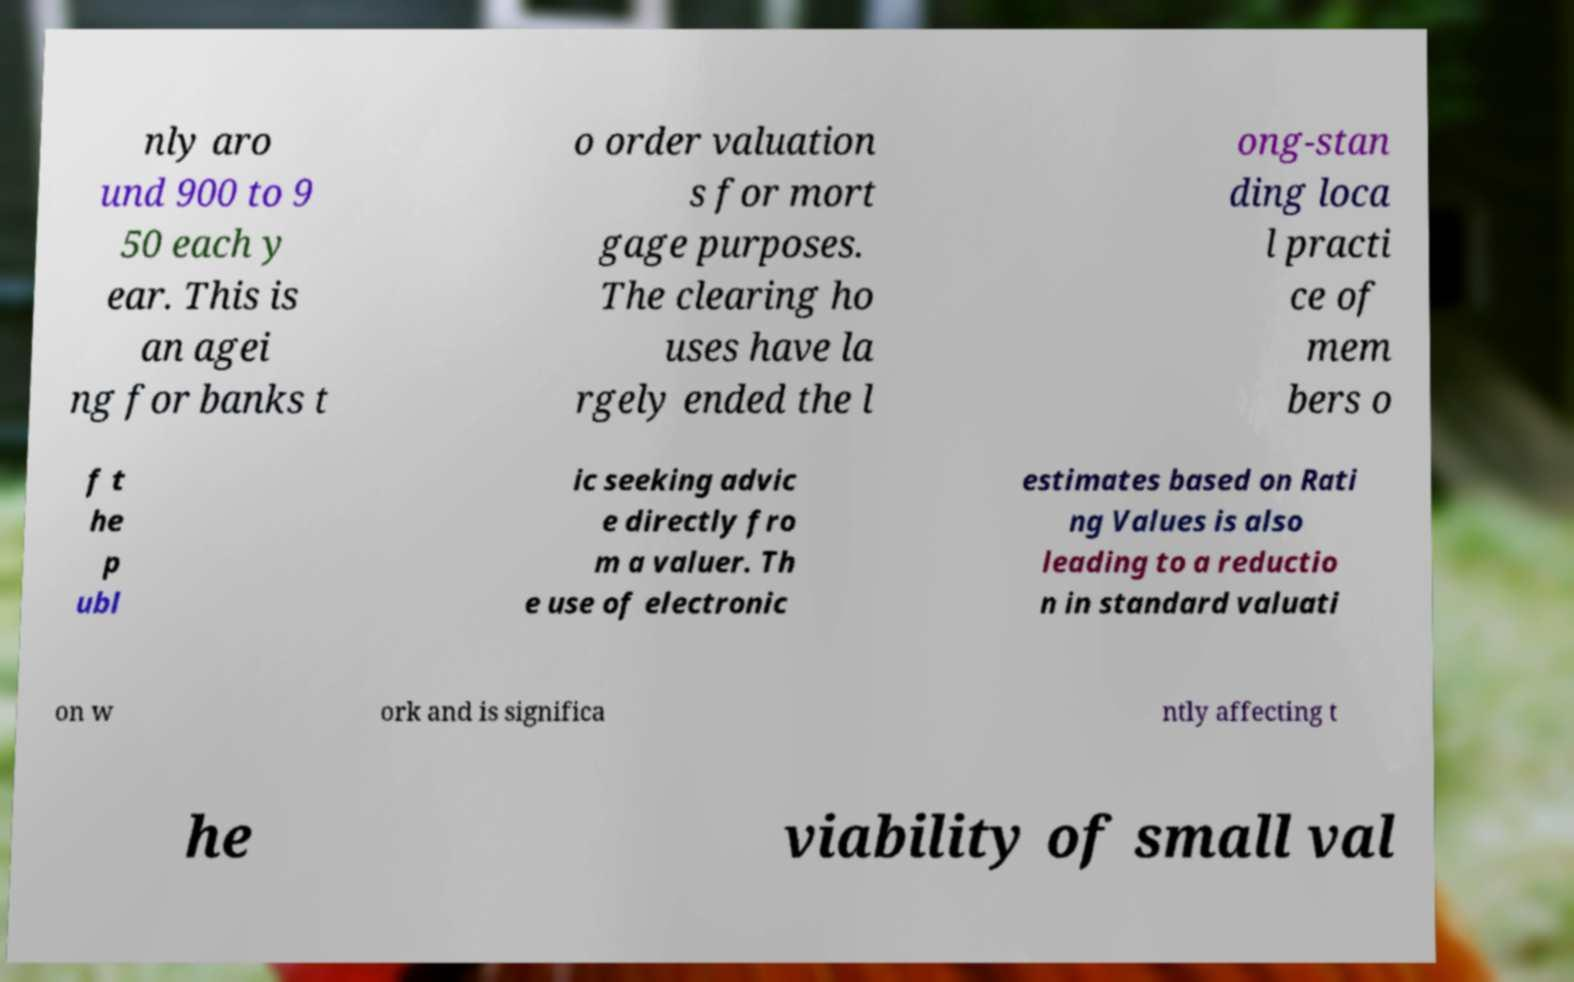Could you assist in decoding the text presented in this image and type it out clearly? nly aro und 900 to 9 50 each y ear. This is an agei ng for banks t o order valuation s for mort gage purposes. The clearing ho uses have la rgely ended the l ong-stan ding loca l practi ce of mem bers o f t he p ubl ic seeking advic e directly fro m a valuer. Th e use of electronic estimates based on Rati ng Values is also leading to a reductio n in standard valuati on w ork and is significa ntly affecting t he viability of small val 